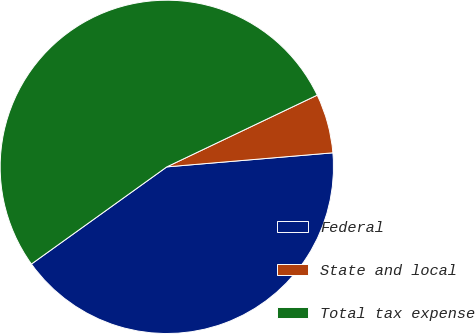Convert chart. <chart><loc_0><loc_0><loc_500><loc_500><pie_chart><fcel>Federal<fcel>State and local<fcel>Total tax expense<nl><fcel>41.44%<fcel>5.74%<fcel>52.83%<nl></chart> 